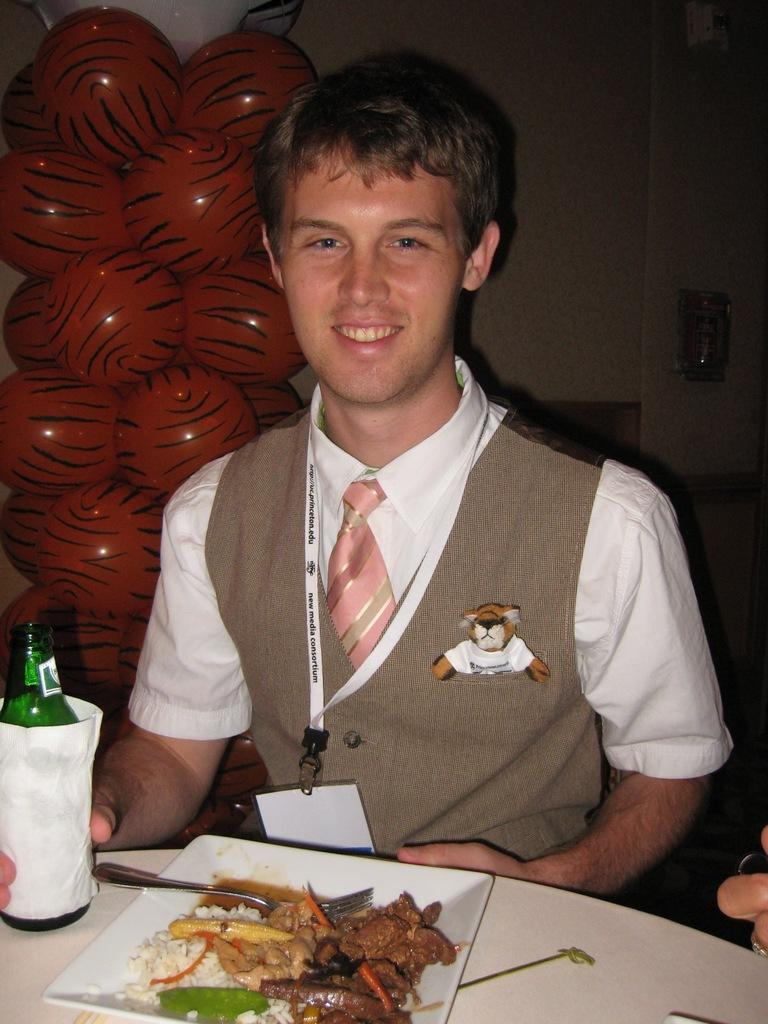What is the man in the image doing? The man is sitting on a chair in the image. Where is the man located in relation to the table? The man is around a table in the image. What can be seen on the table besides the man? There is a food item and a beer bottle on the table. What is visible in the background of the image? There are balloons and a wall in the background of the image. What type of poison is the man using to prepare the food in the image? There is no poison present in the image, and the man is not preparing any food. 